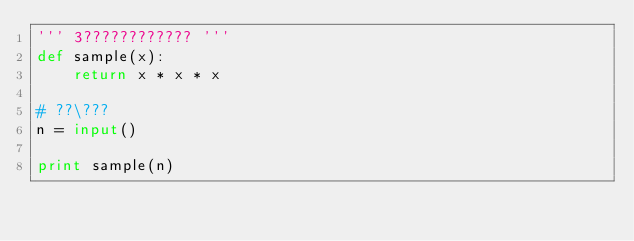<code> <loc_0><loc_0><loc_500><loc_500><_Python_>''' 3???????????? '''
def sample(x):
    return x * x * x 

# ??\???
n = input()

print sample(n)</code> 